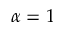<formula> <loc_0><loc_0><loc_500><loc_500>\alpha = 1</formula> 